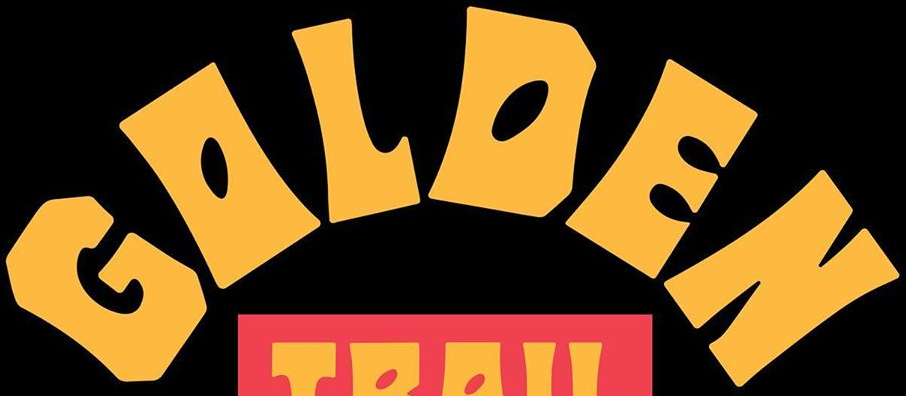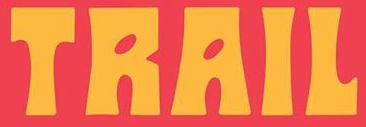What words are shown in these images in order, separated by a semicolon? GOLDEN; TRAIL 